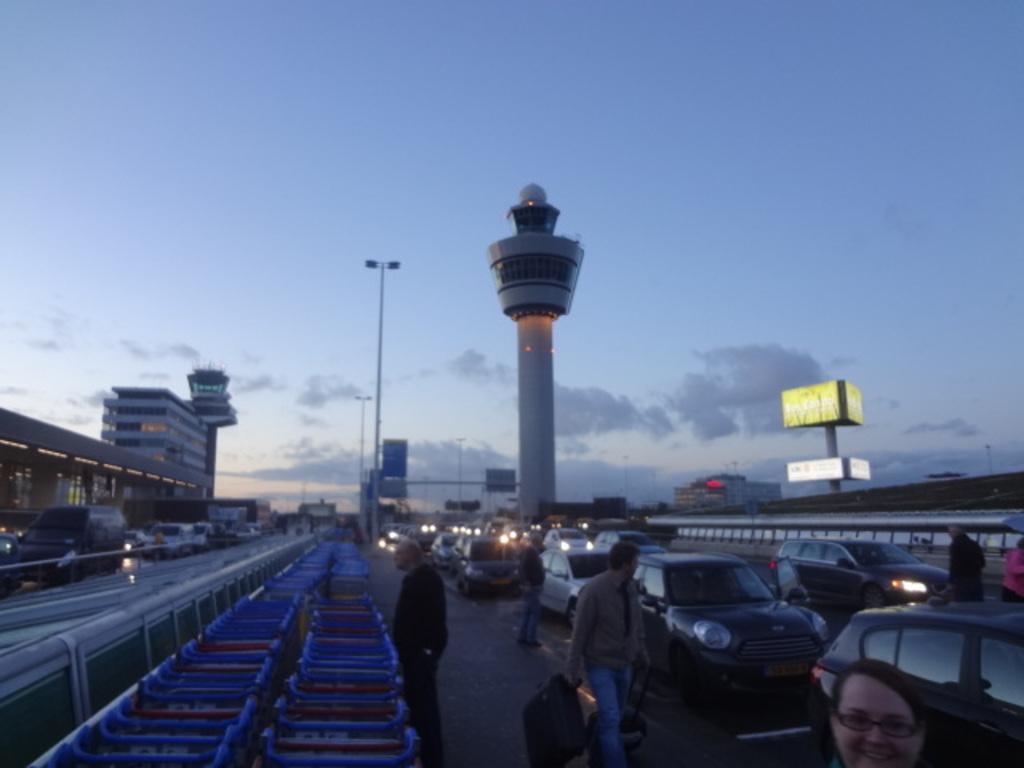Can you describe this image briefly? In this image I see the roads on which there are number of vehicles and I see few people. In the background I see the buildings and I see a tower over here and I see the poles and I see the hoardings over here and I see the sky which is a bit cloudy over here. 